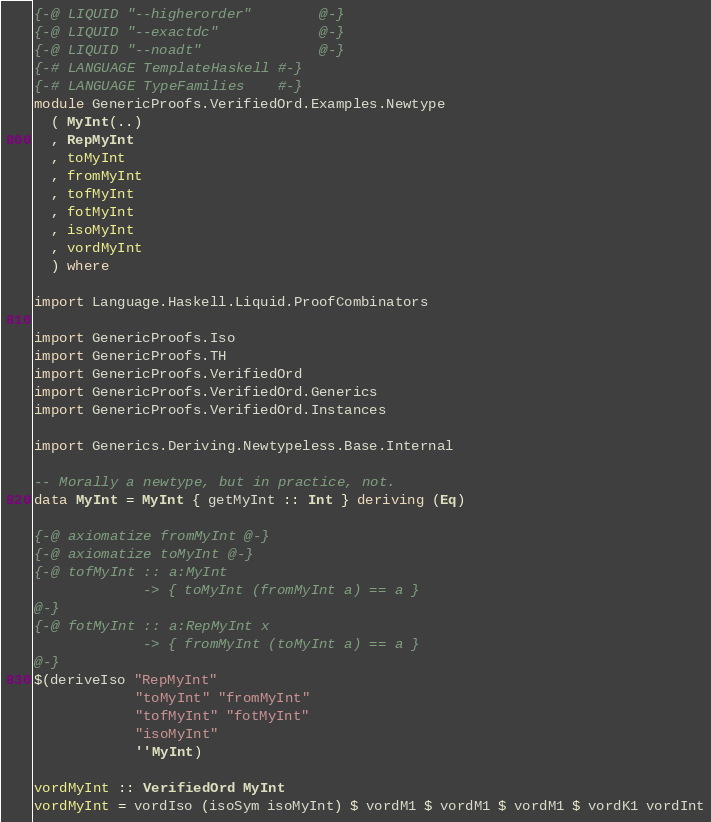<code> <loc_0><loc_0><loc_500><loc_500><_Haskell_>{-@ LIQUID "--higherorder"        @-}
{-@ LIQUID "--exactdc"            @-}
{-@ LIQUID "--noadt"              @-}
{-# LANGUAGE TemplateHaskell #-}
{-# LANGUAGE TypeFamilies    #-}
module GenericProofs.VerifiedOrd.Examples.Newtype
  ( MyInt(..)
  , RepMyInt
  , toMyInt
  , fromMyInt
  , tofMyInt
  , fotMyInt
  , isoMyInt
  , vordMyInt
  ) where

import Language.Haskell.Liquid.ProofCombinators

import GenericProofs.Iso
import GenericProofs.TH
import GenericProofs.VerifiedOrd
import GenericProofs.VerifiedOrd.Generics
import GenericProofs.VerifiedOrd.Instances

import Generics.Deriving.Newtypeless.Base.Internal

-- Morally a newtype, but in practice, not.
data MyInt = MyInt { getMyInt :: Int } deriving (Eq)

{-@ axiomatize fromMyInt @-}
{-@ axiomatize toMyInt @-}
{-@ tofMyInt :: a:MyInt
             -> { toMyInt (fromMyInt a) == a }
@-}
{-@ fotMyInt :: a:RepMyInt x
             -> { fromMyInt (toMyInt a) == a }
@-}
$(deriveIso "RepMyInt"
            "toMyInt" "fromMyInt"
            "tofMyInt" "fotMyInt"
            "isoMyInt"
            ''MyInt)

vordMyInt :: VerifiedOrd MyInt
vordMyInt = vordIso (isoSym isoMyInt) $ vordM1 $ vordM1 $ vordM1 $ vordK1 vordInt
</code> 